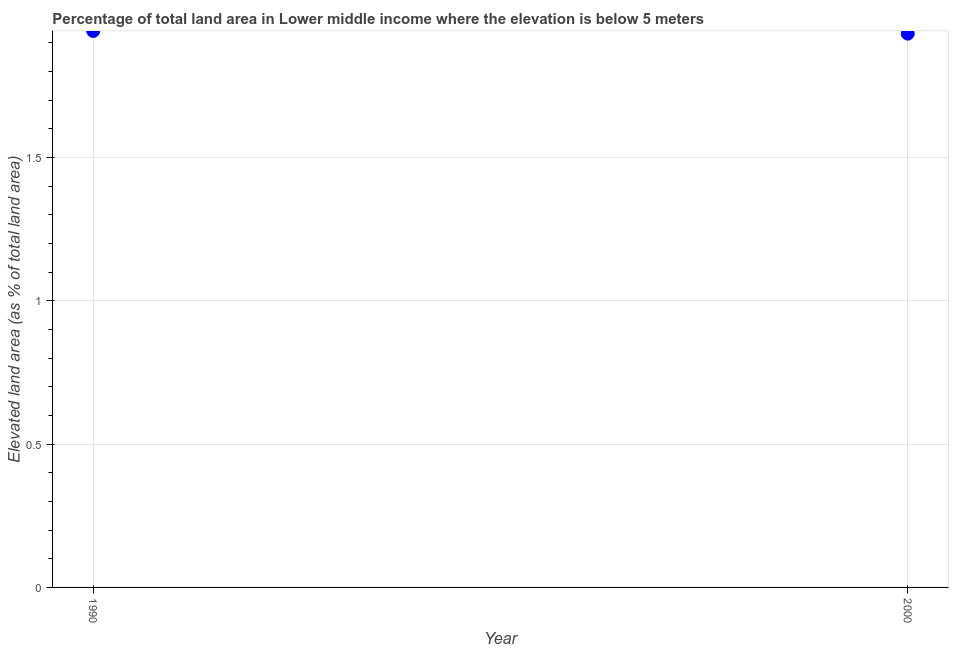What is the total elevated land area in 1990?
Keep it short and to the point. 1.94. Across all years, what is the maximum total elevated land area?
Provide a short and direct response. 1.94. Across all years, what is the minimum total elevated land area?
Your response must be concise. 1.93. In which year was the total elevated land area maximum?
Provide a succinct answer. 1990. What is the sum of the total elevated land area?
Offer a very short reply. 3.87. What is the difference between the total elevated land area in 1990 and 2000?
Provide a short and direct response. 0.01. What is the average total elevated land area per year?
Your answer should be very brief. 1.94. What is the median total elevated land area?
Provide a succinct answer. 1.94. In how many years, is the total elevated land area greater than 0.9 %?
Ensure brevity in your answer.  2. Do a majority of the years between 2000 and 1990 (inclusive) have total elevated land area greater than 0.2 %?
Provide a succinct answer. No. What is the ratio of the total elevated land area in 1990 to that in 2000?
Provide a succinct answer. 1. Is the total elevated land area in 1990 less than that in 2000?
Your answer should be compact. No. In how many years, is the total elevated land area greater than the average total elevated land area taken over all years?
Offer a very short reply. 1. Does the total elevated land area monotonically increase over the years?
Your answer should be compact. No. How many years are there in the graph?
Your answer should be compact. 2. Does the graph contain any zero values?
Keep it short and to the point. No. What is the title of the graph?
Keep it short and to the point. Percentage of total land area in Lower middle income where the elevation is below 5 meters. What is the label or title of the Y-axis?
Provide a succinct answer. Elevated land area (as % of total land area). What is the Elevated land area (as % of total land area) in 1990?
Offer a terse response. 1.94. What is the Elevated land area (as % of total land area) in 2000?
Offer a terse response. 1.93. What is the difference between the Elevated land area (as % of total land area) in 1990 and 2000?
Make the answer very short. 0.01. What is the ratio of the Elevated land area (as % of total land area) in 1990 to that in 2000?
Keep it short and to the point. 1. 